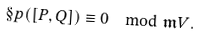Convert formula to latex. <formula><loc_0><loc_0><loc_500><loc_500>\S p ( [ P , Q ] ) \equiv 0 \mod \mathfrak { m } V .</formula> 